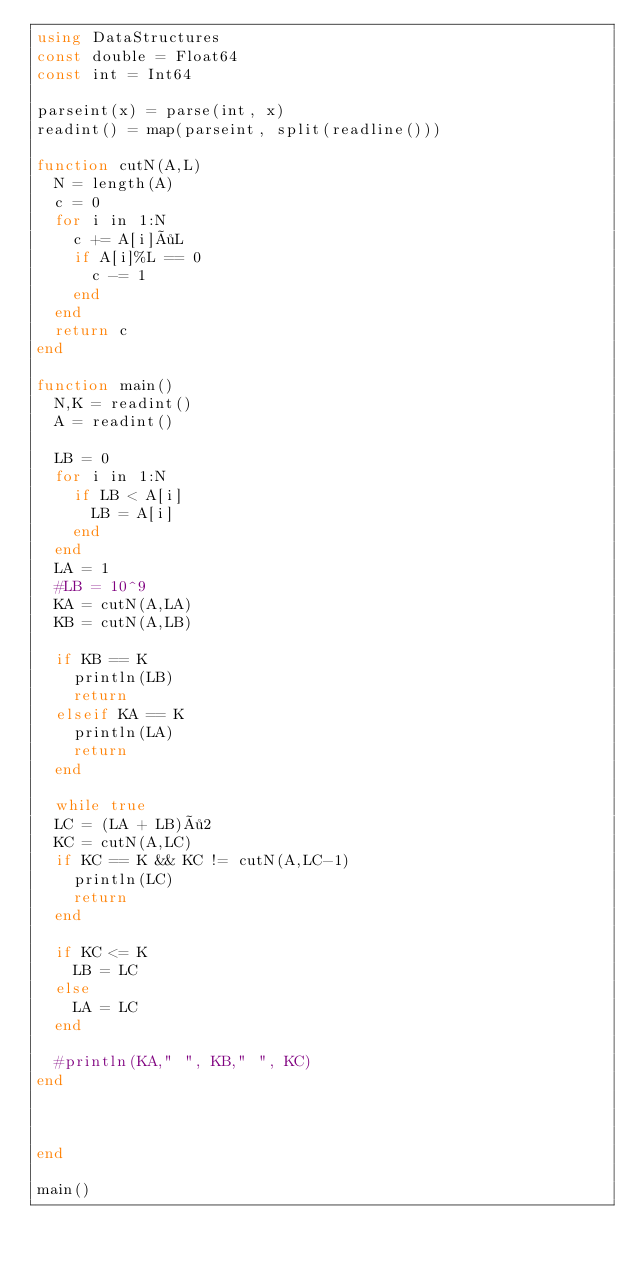Convert code to text. <code><loc_0><loc_0><loc_500><loc_500><_Julia_>using DataStructures
const double = Float64
const int = Int64

parseint(x) = parse(int, x)
readint() = map(parseint, split(readline()))

function cutN(A,L)
  N = length(A)
  c = 0
  for i in 1:N
    c += A[i]÷L
    if A[i]%L == 0
      c -= 1
    end
  end
  return c
end

function main()
  N,K = readint()
  A = readint()

  LB = 0
  for i in 1:N
    if LB < A[i]
      LB = A[i]
    end
  end
  LA = 1
  #LB = 10^9
  KA = cutN(A,LA)
  KB = cutN(A,LB)

  if KB == K
    println(LB)
    return
  elseif KA == K
    println(LA)
    return
  end

  while true
  LC = (LA + LB)÷2
  KC = cutN(A,LC)
  if KC == K && KC != cutN(A,LC-1)
    println(LC)
    return
  end

  if KC <= K
    LB = LC
  else
    LA = LC
  end

  #println(KA," ", KB," ", KC)
end  



end

main()</code> 